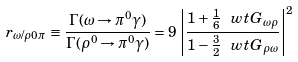Convert formula to latex. <formula><loc_0><loc_0><loc_500><loc_500>r _ { \omega / \rho 0 \pi } \equiv \frac { \Gamma ( \omega \to \pi ^ { 0 } \gamma ) } { \Gamma ( \rho ^ { 0 } \to \pi ^ { 0 } \gamma ) } = 9 \, \left | \frac { 1 + \frac { 1 } { 6 } \, \ w t G _ { \omega \rho } } { 1 - \frac { 3 } { 2 } \, \ w t G _ { \rho \omega } } \right | ^ { 2 }</formula> 